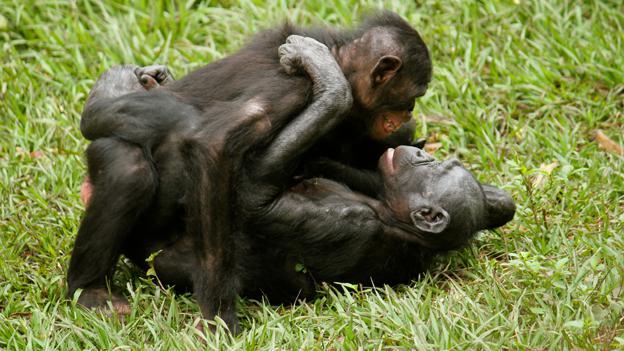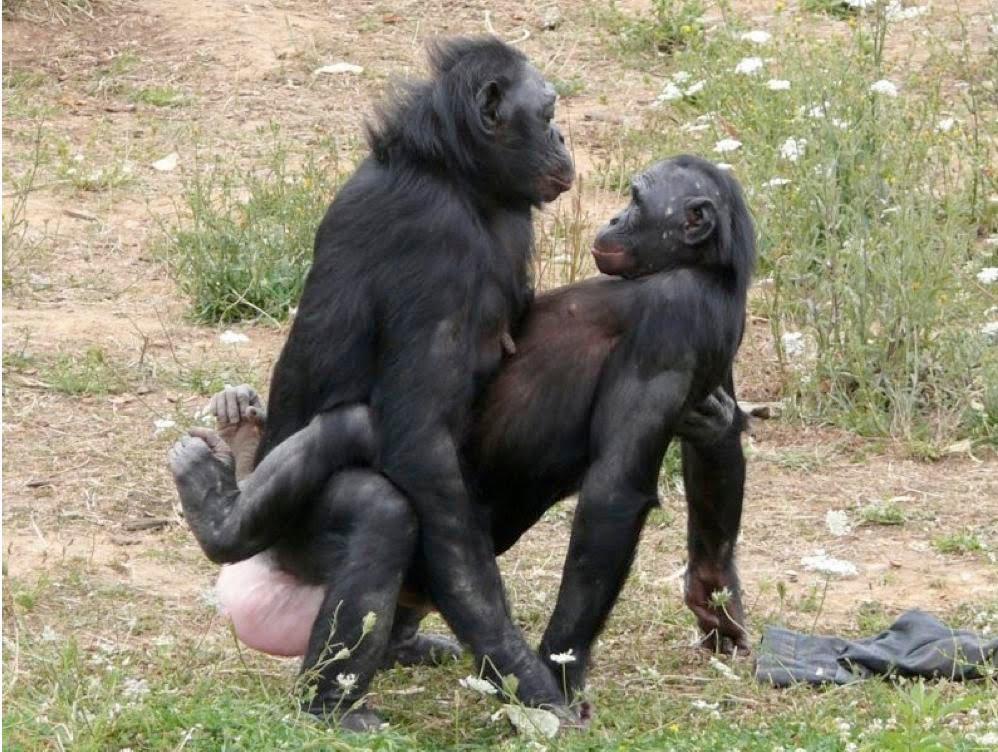The first image is the image on the left, the second image is the image on the right. For the images displayed, is the sentence "At least one of the monkeys is a baby." factually correct? Answer yes or no. No. The first image is the image on the left, the second image is the image on the right. Examine the images to the left and right. Is the description "there is a mother chimp holding her infant" accurate? Answer yes or no. No. 